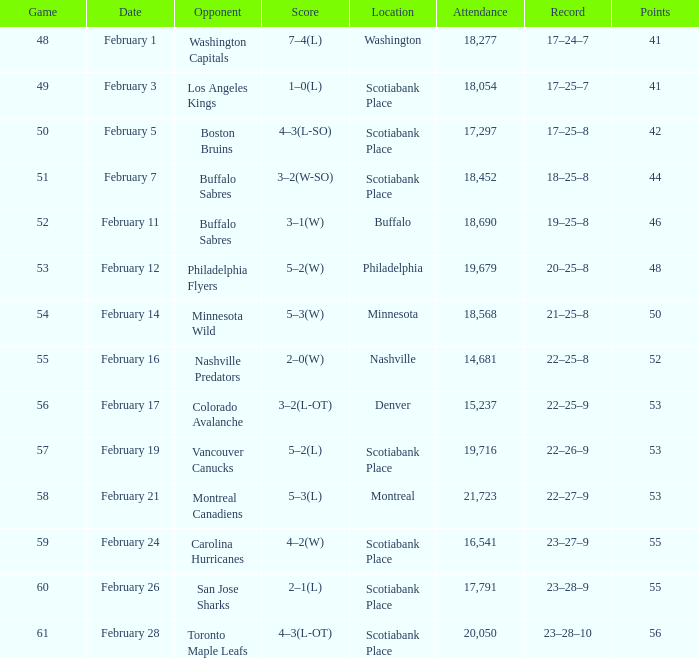What sum of game has an attendance of 18,690? 52.0. 